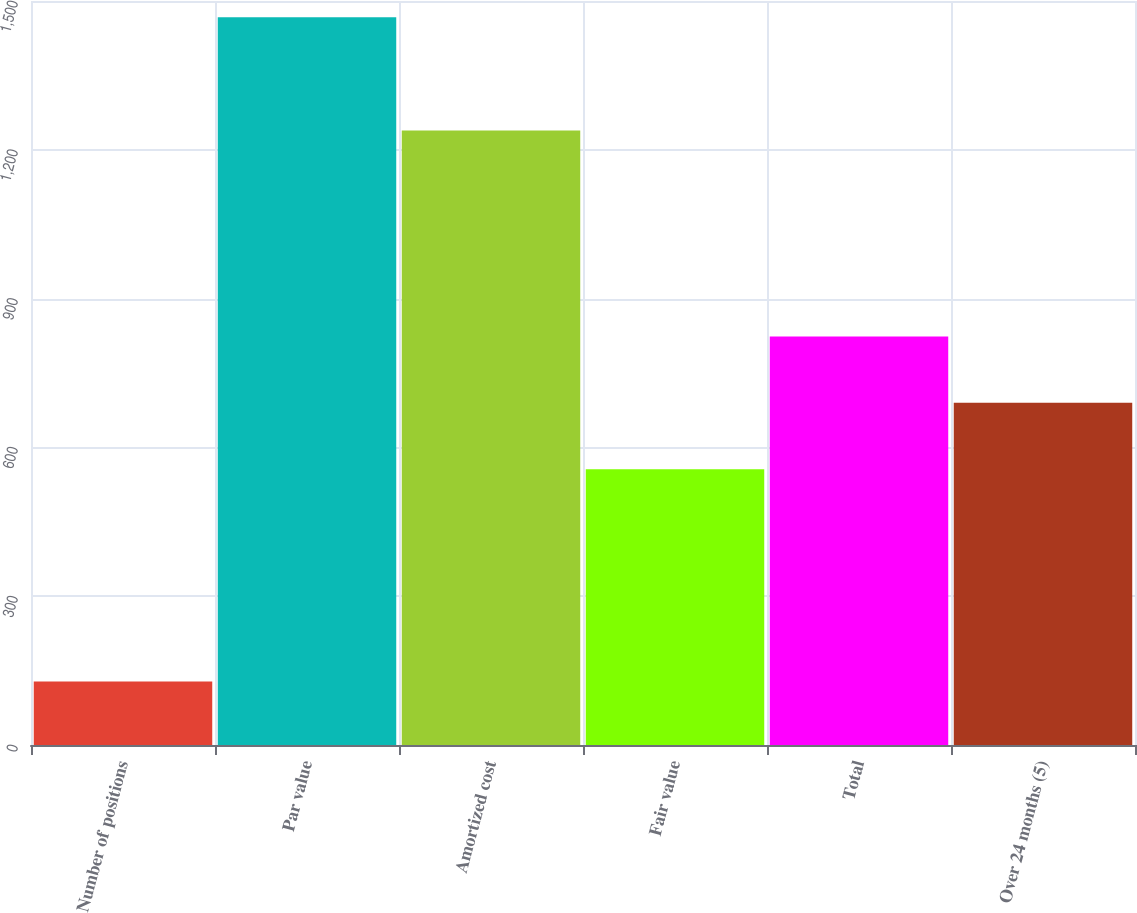Convert chart. <chart><loc_0><loc_0><loc_500><loc_500><bar_chart><fcel>Number of positions<fcel>Par value<fcel>Amortized cost<fcel>Fair value<fcel>Total<fcel>Over 24 months (5)<nl><fcel>128<fcel>1467<fcel>1239<fcel>556<fcel>823.8<fcel>689.9<nl></chart> 